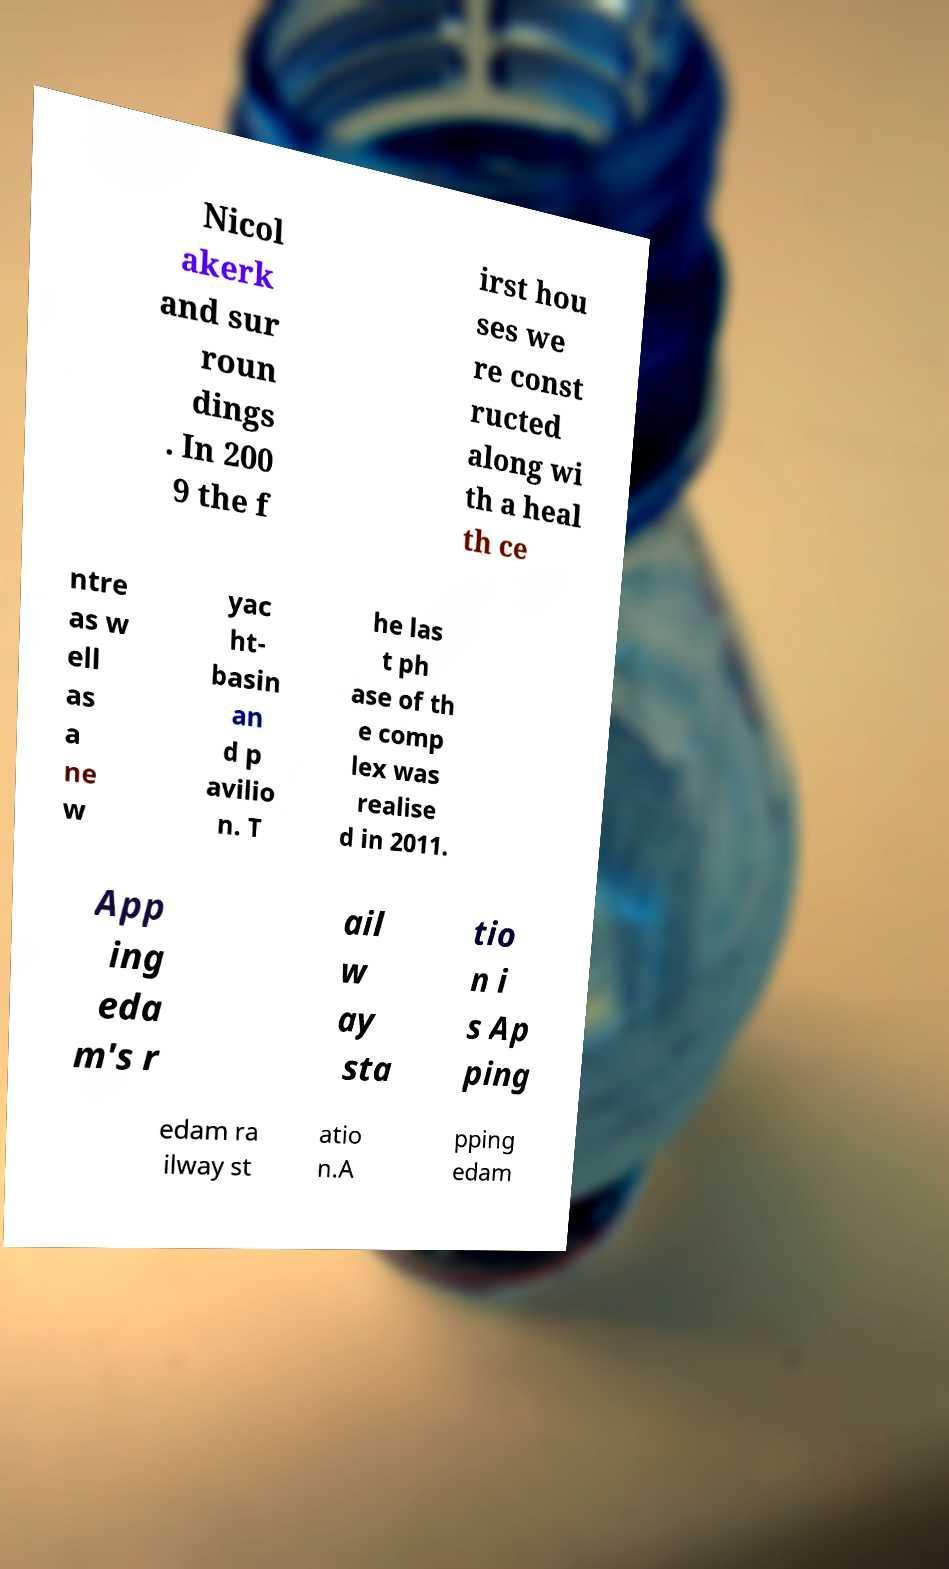What messages or text are displayed in this image? I need them in a readable, typed format. Nicol akerk and sur roun dings . In 200 9 the f irst hou ses we re const ructed along wi th a heal th ce ntre as w ell as a ne w yac ht- basin an d p avilio n. T he las t ph ase of th e comp lex was realise d in 2011. App ing eda m's r ail w ay sta tio n i s Ap ping edam ra ilway st atio n.A pping edam 